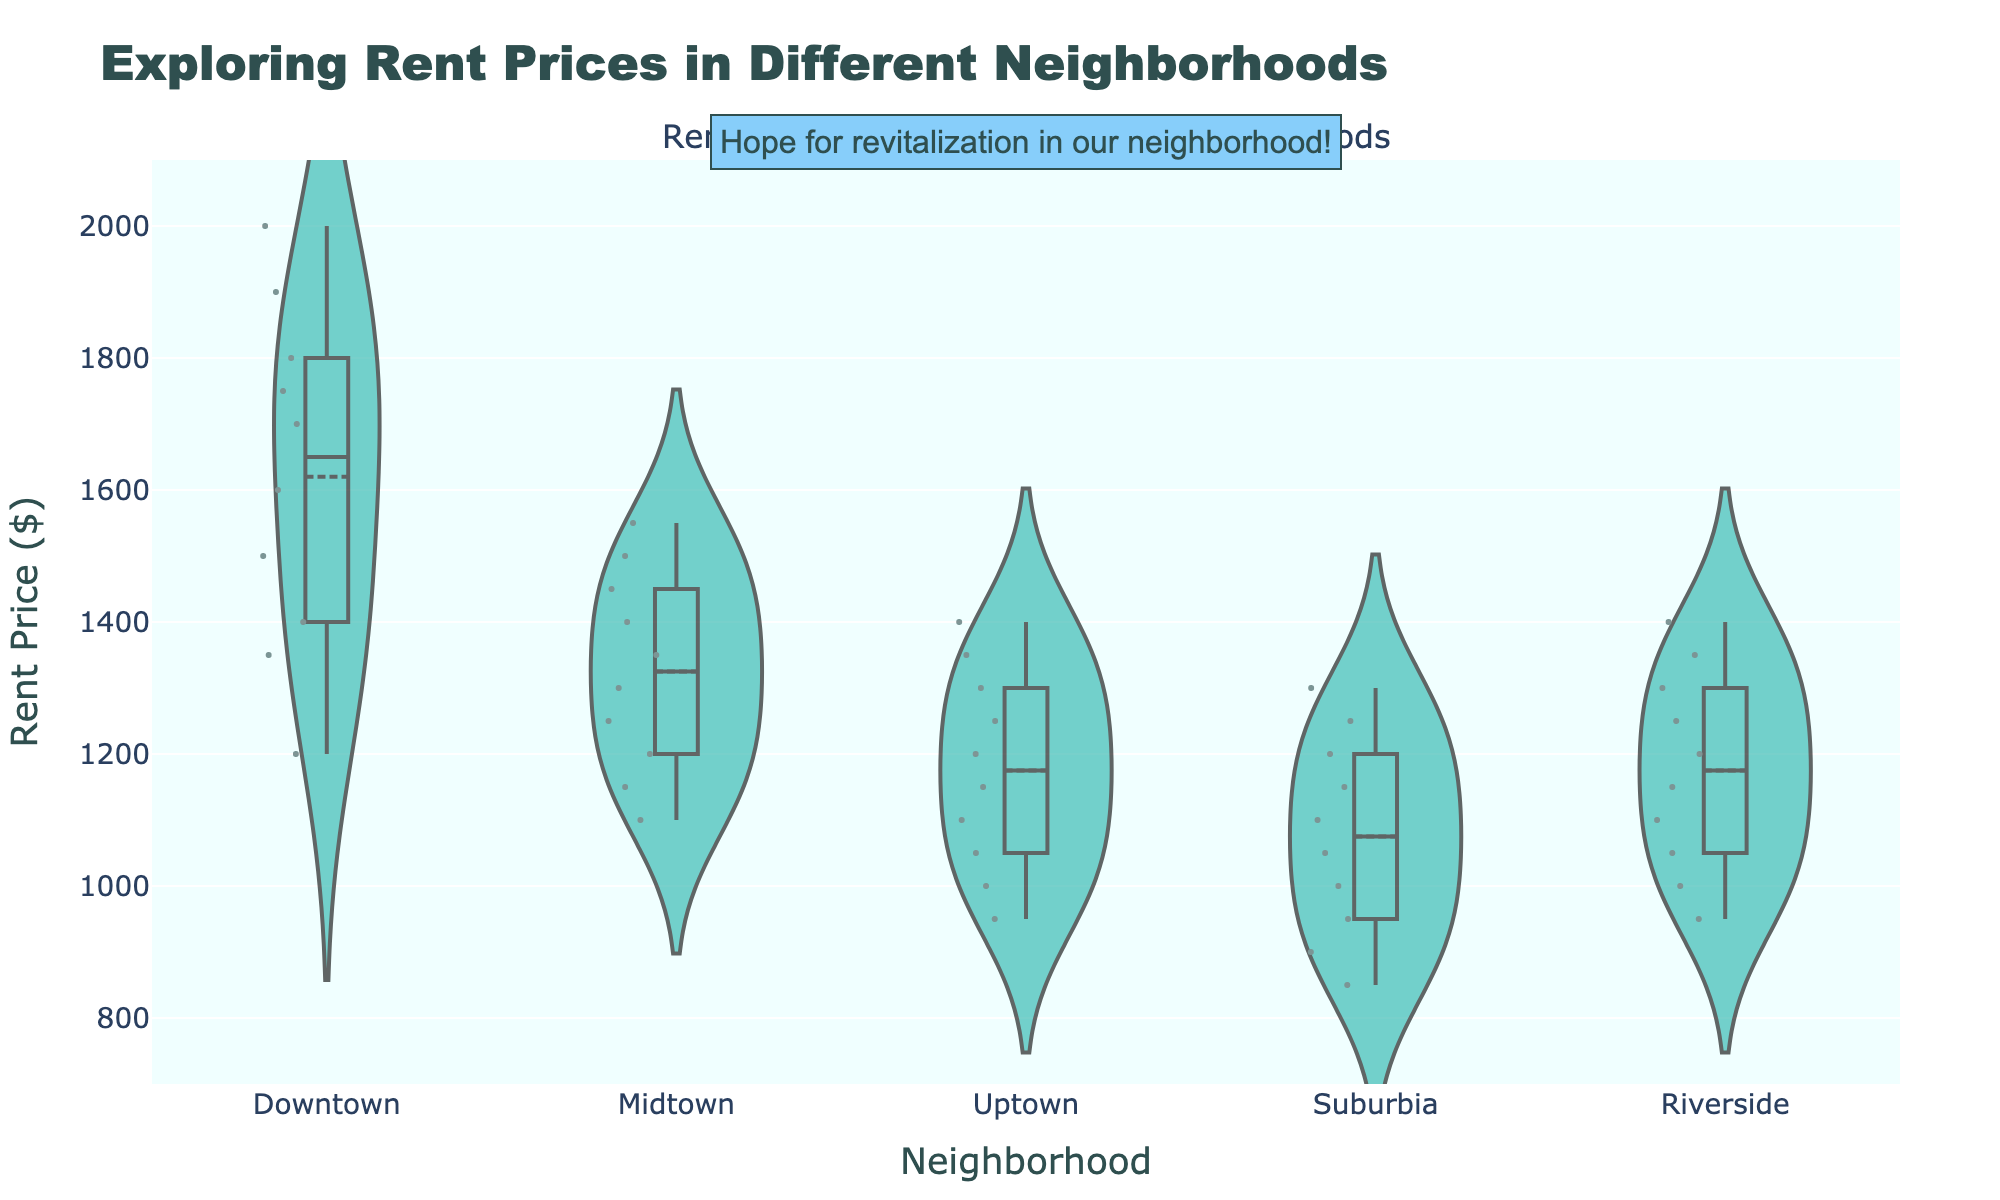What is the title of the plot? The title of the plot is displayed prominently at the top and it states the main purpose of the visualization.
Answer: Exploring Rent Prices in Different Neighborhoods What are the neighborhoods shown on the x-axis? The x-axis labels represent different neighborhoods where the rent price data is plotted.
Answer: Downtown, Midtown, Uptown, Suburbia, Riverside What is the general range of rent prices shown on the y-axis? The y-axis indicates the rent prices across different neighborhoods, showing the scale and range of rent prices.
Answer: $700 to $2100 Which neighborhood shows the highest median rent price? Median is indicated by a line within the violin plot, and you can observe which neighborhood's violin has the highest median line.
Answer: Downtown Which neighborhood has the widest distribution of rent prices? The width of the violins at different points indicates the density of rent prices, hence the neighborhood with the widest spread violin has the widest distribution.
Answer: Downtown How does the rent price in Uptown compare to Suburbia? By comparing the median lines and the spread of the violins for Uptown and Suburbia, we can determine how the rent prices differ between these two neighborhoods.
Answer: Higher in Uptown Which neighborhood seems to have the most variability in rent prices? Variability can be inferred from the spread and shape of the violins; the more spread out the points and wider the violin, the more variability there is.
Answer: Downtown What neighborhood has the lowest upper bound of rent prices? The upper bound can be determined from the highest points on the violins for each neighborhood.
Answer: Suburbia Is there any neighborhood with an overlapping range of data points with Downtown? By observing the spread of the data points within the violins, you can see if there's any overlap in rent prices between Downtown and other neighborhoods.
Answer: Yes, Midtown Between Riverside and Uptown, which neighborhood has a lower general rent price? I can compare the median and the range of the rent prices directly from the visualization.
Answer: Riverside 